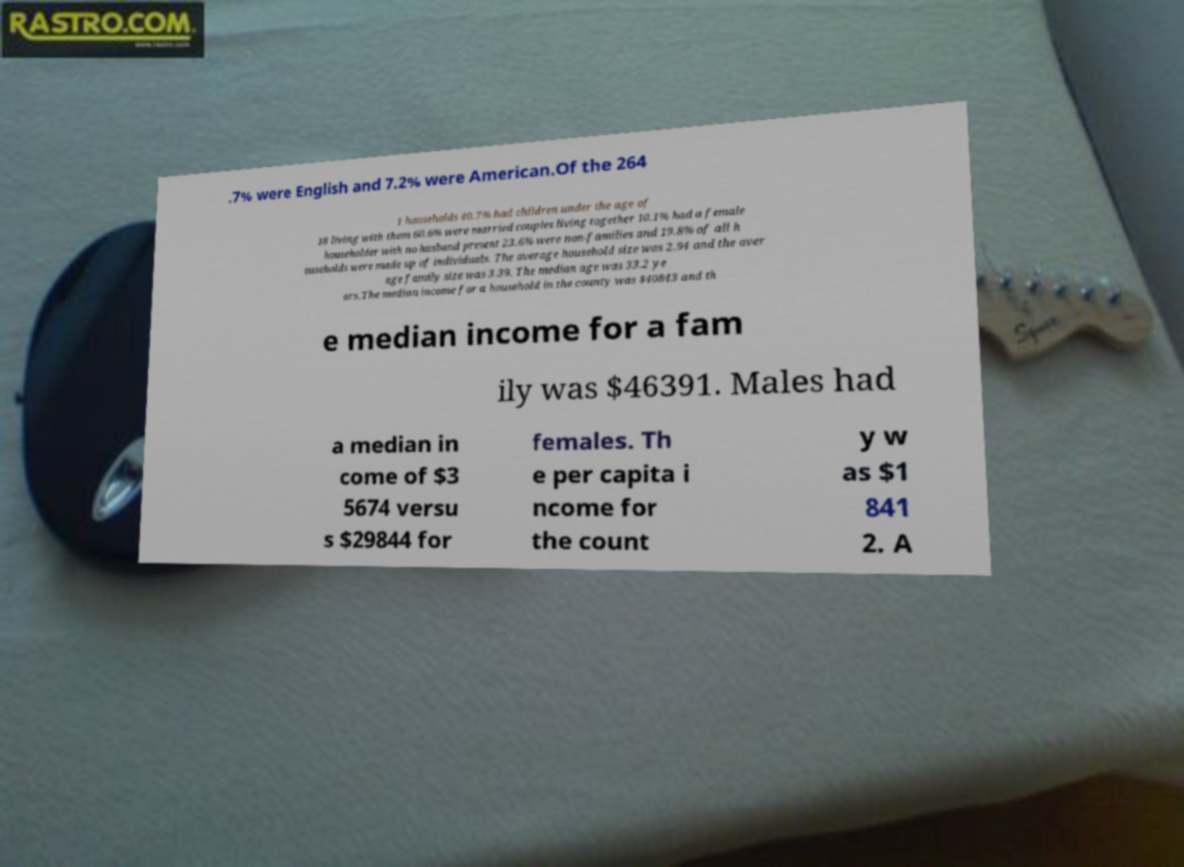Could you assist in decoding the text presented in this image and type it out clearly? .7% were English and 7.2% were American.Of the 264 1 households 40.7% had children under the age of 18 living with them 60.6% were married couples living together 10.1% had a female householder with no husband present 23.6% were non-families and 19.8% of all h ouseholds were made up of individuals. The average household size was 2.94 and the aver age family size was 3.39. The median age was 33.2 ye ars.The median income for a household in the county was $40843 and th e median income for a fam ily was $46391. Males had a median in come of $3 5674 versu s $29844 for females. Th e per capita i ncome for the count y w as $1 841 2. A 